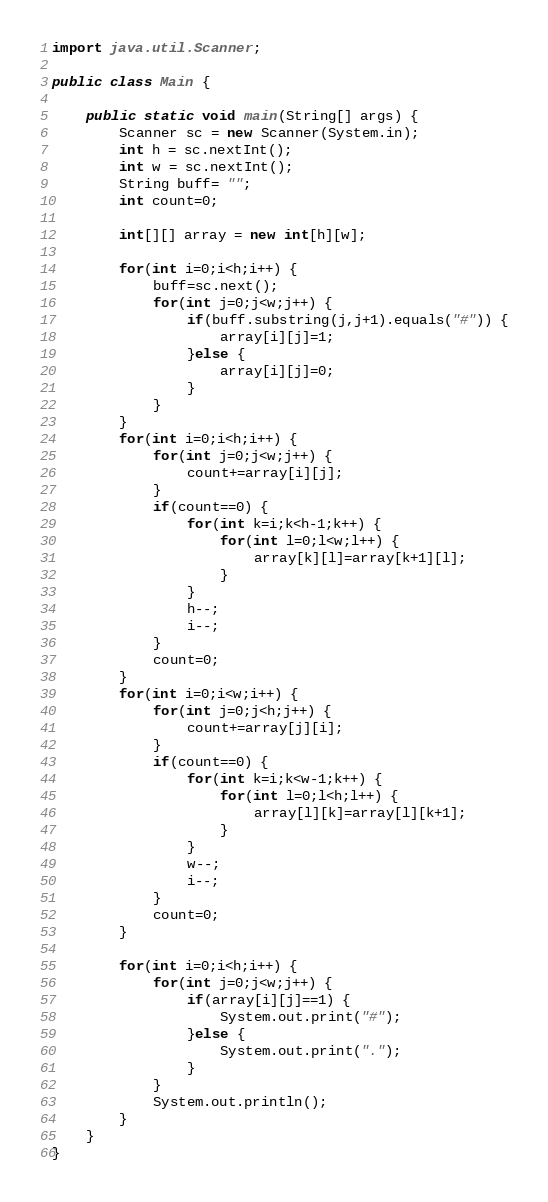Convert code to text. <code><loc_0><loc_0><loc_500><loc_500><_Java_>import java.util.Scanner;

public class Main {

	public static void main(String[] args) {
		Scanner sc = new Scanner(System.in);
		int h = sc.nextInt();
		int w = sc.nextInt();
		String buff= "";
		int count=0;

		int[][] array = new int[h][w];

		for(int i=0;i<h;i++) {
			buff=sc.next();
			for(int j=0;j<w;j++) {
				if(buff.substring(j,j+1).equals("#")) {
					array[i][j]=1;
				}else {
					array[i][j]=0;
				}
			}
		}
		for(int i=0;i<h;i++) {
			for(int j=0;j<w;j++) {
				count+=array[i][j];
			}
			if(count==0) {
				for(int k=i;k<h-1;k++) {
					for(int l=0;l<w;l++) {
						array[k][l]=array[k+1][l];
					}
				}
				h--;
				i--;
			}
			count=0;
		}
		for(int i=0;i<w;i++) {
			for(int j=0;j<h;j++) {
				count+=array[j][i];
			}
			if(count==0) {
				for(int k=i;k<w-1;k++) {
					for(int l=0;l<h;l++) {
						array[l][k]=array[l][k+1];
					}
				}
				w--;
				i--;
			}
			count=0;
		}

		for(int i=0;i<h;i++) {
			for(int j=0;j<w;j++) {
				if(array[i][j]==1) {
					System.out.print("#");
				}else {
					System.out.print(".");
				}
			}
			System.out.println();
		}
	}
}


</code> 